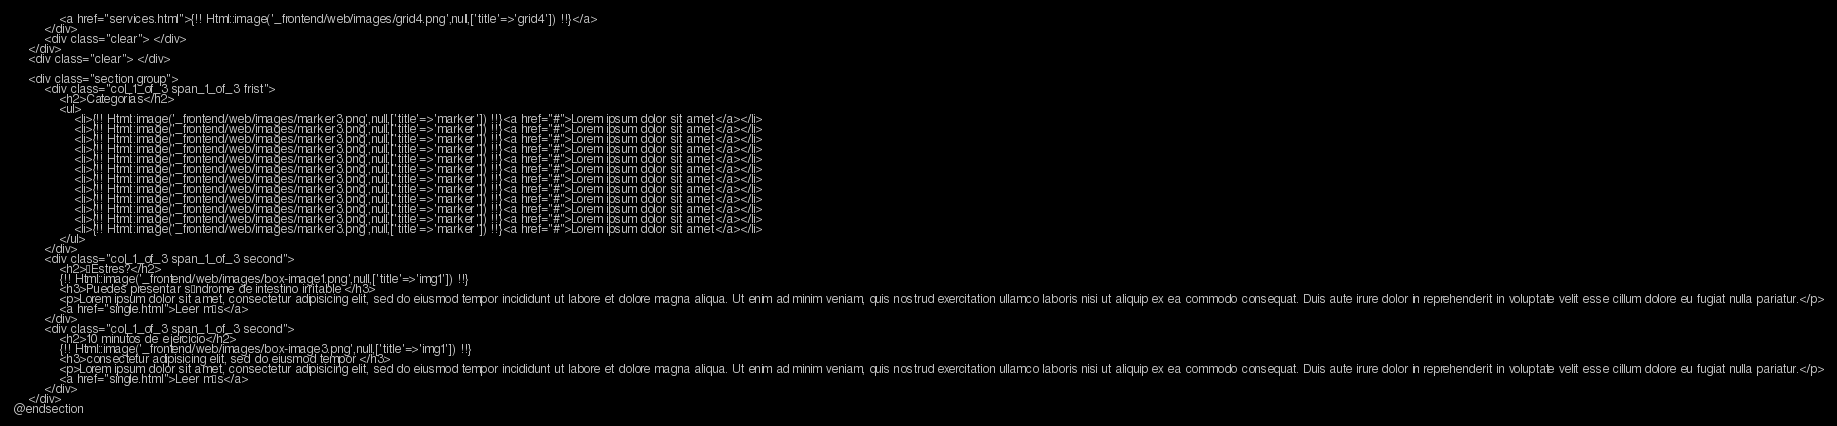<code> <loc_0><loc_0><loc_500><loc_500><_PHP_>            <a href="services.html">{!! Html::image('_frontend/web/images/grid4.png',null,['title'=>'grid4']) !!}</a>
        </div>
        <div class="clear"> </div>
    </div>
    <div class="clear"> </div>

    <div class="section group">
        <div class="col_1_of_3 span_1_of_3 frist">
            <h2>Categorias</h2>
            <ul>
                <li>{!! Html::image('_frontend/web/images/marker3.png',null,['title'=>'marker']) !!}<a href="#">Lorem ipsum dolor sit amet</a></li>
                <li>{!! Html::image('_frontend/web/images/marker3.png',null,['title'=>'marker']) !!}<a href="#">Lorem ipsum dolor sit amet</a></li>
                <li>{!! Html::image('_frontend/web/images/marker3.png',null,['title'=>'marker']) !!}<a href="#">Lorem ipsum dolor sit amet</a></li>
                <li>{!! Html::image('_frontend/web/images/marker3.png',null,['title'=>'marker']) !!}<a href="#">Lorem ipsum dolor sit amet</a></li>
                <li>{!! Html::image('_frontend/web/images/marker3.png',null,['title'=>'marker']) !!}<a href="#">Lorem ipsum dolor sit amet</a></li>
                <li>{!! Html::image('_frontend/web/images/marker3.png',null,['title'=>'marker']) !!}<a href="#">Lorem ipsum dolor sit amet</a></li>
                <li>{!! Html::image('_frontend/web/images/marker3.png',null,['title'=>'marker']) !!}<a href="#">Lorem ipsum dolor sit amet</a></li>
                <li>{!! Html::image('_frontend/web/images/marker3.png',null,['title'=>'marker']) !!}<a href="#">Lorem ipsum dolor sit amet</a></li>
                <li>{!! Html::image('_frontend/web/images/marker3.png',null,['title'=>'marker']) !!}<a href="#">Lorem ipsum dolor sit amet</a></li>
                <li>{!! Html::image('_frontend/web/images/marker3.png',null,['title'=>'marker']) !!}<a href="#">Lorem ipsum dolor sit amet</a></li>
                <li>{!! Html::image('_frontend/web/images/marker3.png',null,['title'=>'marker']) !!}<a href="#">Lorem ipsum dolor sit amet</a></li>
                <li>{!! Html::image('_frontend/web/images/marker3.png',null,['title'=>'marker']) !!}<a href="#">Lorem ipsum dolor sit amet</a></li>
            </ul>
        </div>
        <div class="col_1_of_3 span_1_of_3 second">
            <h2>¿Estres?</h2>
            {!! Html::image('_frontend/web/images/box-image1.png',null,['title'=>'img1']) !!}
            <h3>Puedes presentar síndrome de intestino irritable </h3>
            <p>Lorem ipsum dolor sit amet, consectetur adipisicing elit, sed do eiusmod tempor incididunt ut labore et dolore magna aliqua. Ut enim ad minim veniam, quis nostrud exercitation ullamco laboris nisi ut aliquip ex ea commodo consequat. Duis aute irure dolor in reprehenderit in voluptate velit esse cillum dolore eu fugiat nulla pariatur.</p>
            <a href="single.html">Leer más</a>
        </div>
        <div class="col_1_of_3 span_1_of_3 second">
            <h2>10 minutos de ejercicio</h2>
            {!! Html::image('_frontend/web/images/box-image3.png',null,['title'=>'img1']) !!}
            <h3>consectetur adipisicing elit, sed do eiusmod tempor </h3>
            <p>Lorem ipsum dolor sit amet, consectetur adipisicing elit, sed do eiusmod tempor incididunt ut labore et dolore magna aliqua. Ut enim ad minim veniam, quis nostrud exercitation ullamco laboris nisi ut aliquip ex ea commodo consequat. Duis aute irure dolor in reprehenderit in voluptate velit esse cillum dolore eu fugiat nulla pariatur.</p>
            <a href="single.html">Leer más</a>
        </div>
    </div>
@endsection</code> 